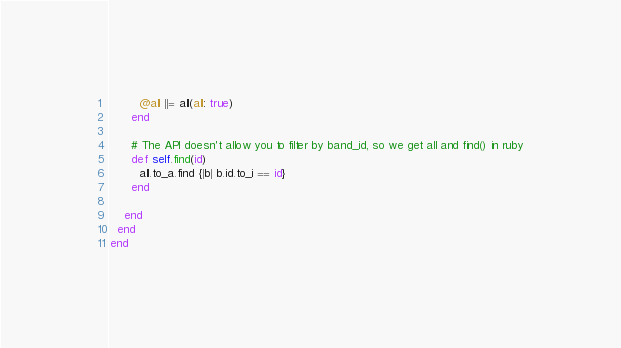<code> <loc_0><loc_0><loc_500><loc_500><_Ruby_>        @all ||= all(all: true)
      end

      # The API doesn't allow you to filter by band_id, so we get all and find() in ruby
      def self.find(id)
        all.to_a.find {|b| b.id.to_i == id}
      end

    end
  end
end</code> 